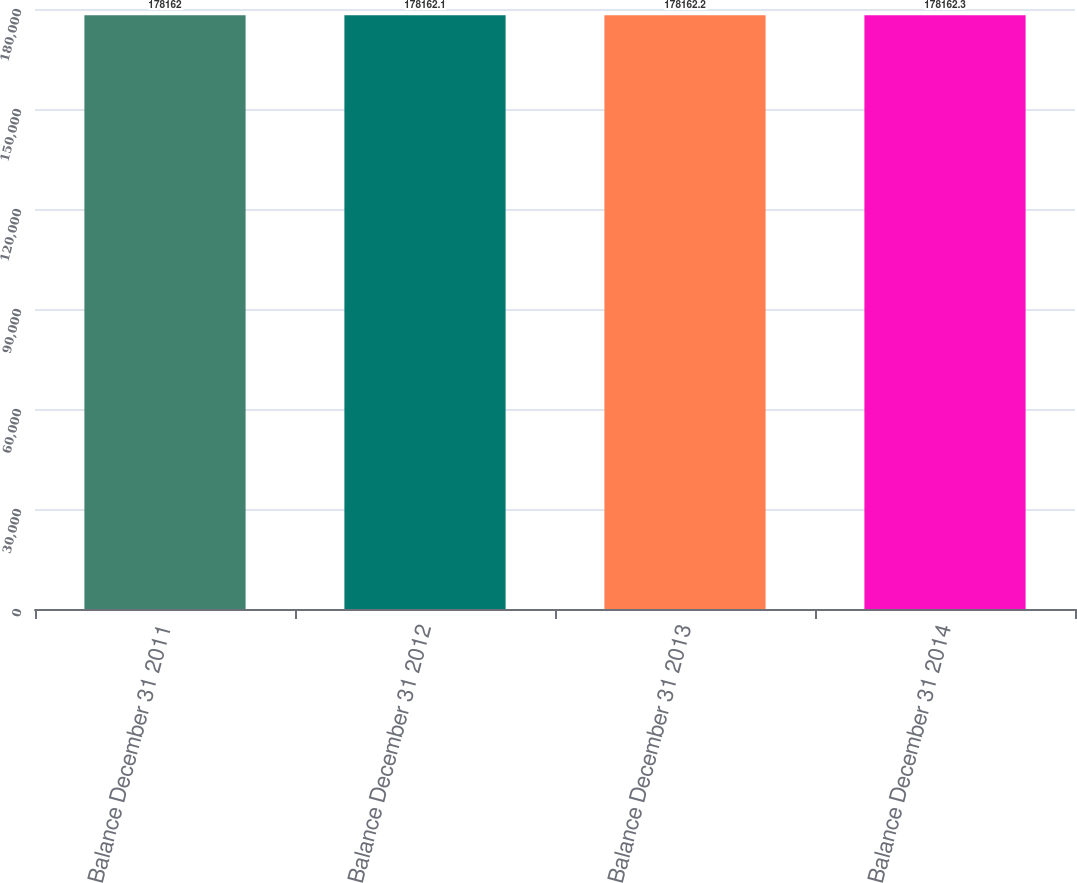Convert chart. <chart><loc_0><loc_0><loc_500><loc_500><bar_chart><fcel>Balance December 31 2011<fcel>Balance December 31 2012<fcel>Balance December 31 2013<fcel>Balance December 31 2014<nl><fcel>178162<fcel>178162<fcel>178162<fcel>178162<nl></chart> 